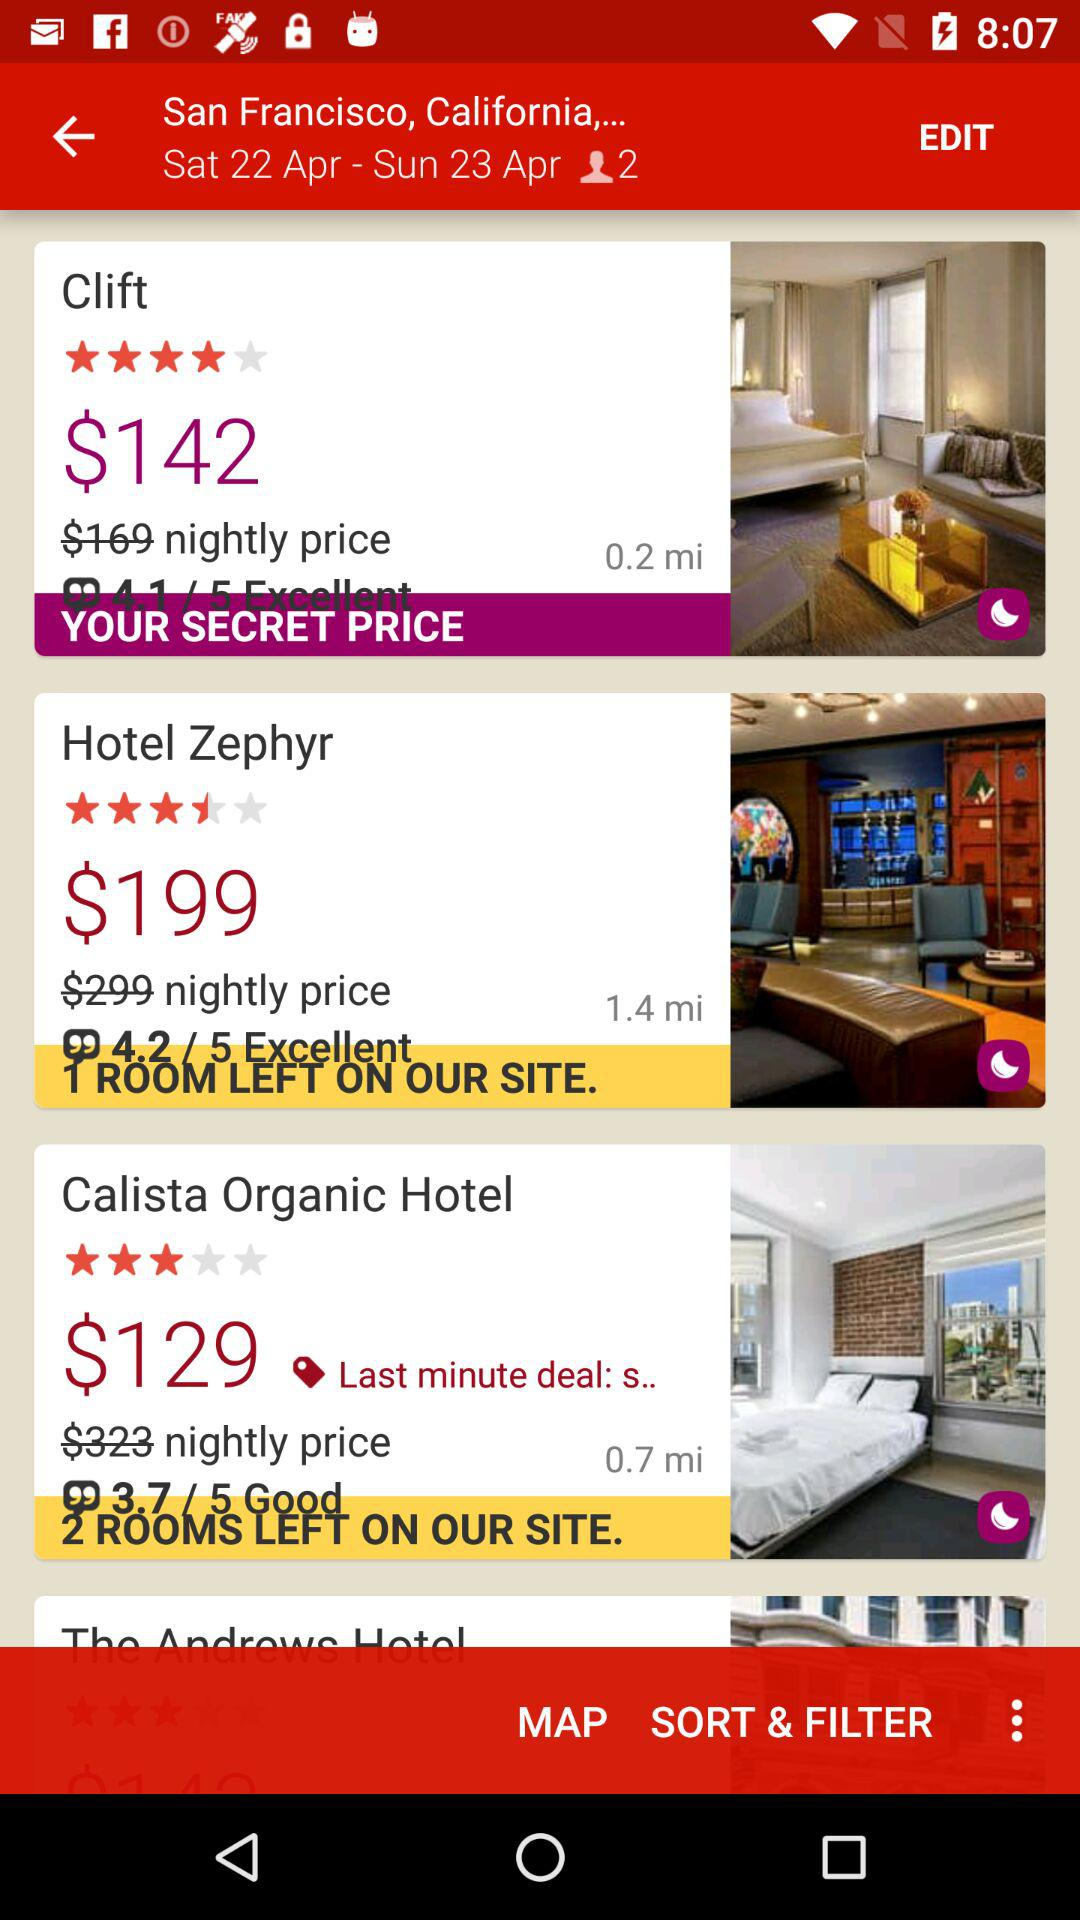What is the selected location for hotels? The selected location is San Francisco, California. 